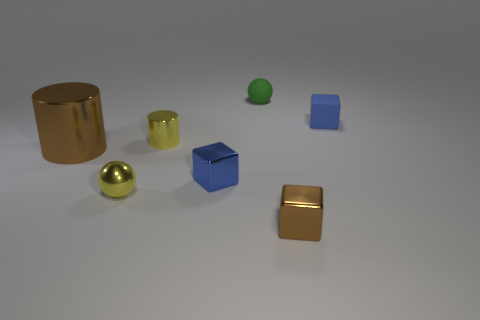Is there a metal cylinder of the same color as the tiny matte ball?
Offer a terse response. No. How many things are blocks on the right side of the small blue metallic block or small spheres that are on the right side of the metallic sphere?
Provide a short and direct response. 3. Are there any tiny green balls that are right of the rubber object right of the green rubber thing?
Offer a very short reply. No. There is a blue matte object that is the same size as the matte ball; what is its shape?
Your response must be concise. Cube. How many objects are small yellow things that are to the left of the yellow metallic cylinder or small green metal balls?
Your response must be concise. 1. How many other things are the same material as the small cylinder?
Offer a very short reply. 4. The shiny thing that is the same color as the small cylinder is what shape?
Offer a very short reply. Sphere. What is the size of the sphere to the left of the green ball?
Offer a terse response. Small. There is a large brown object that is the same material as the tiny cylinder; what shape is it?
Make the answer very short. Cylinder. Do the yellow cylinder and the blue object that is in front of the big cylinder have the same material?
Give a very brief answer. Yes. 